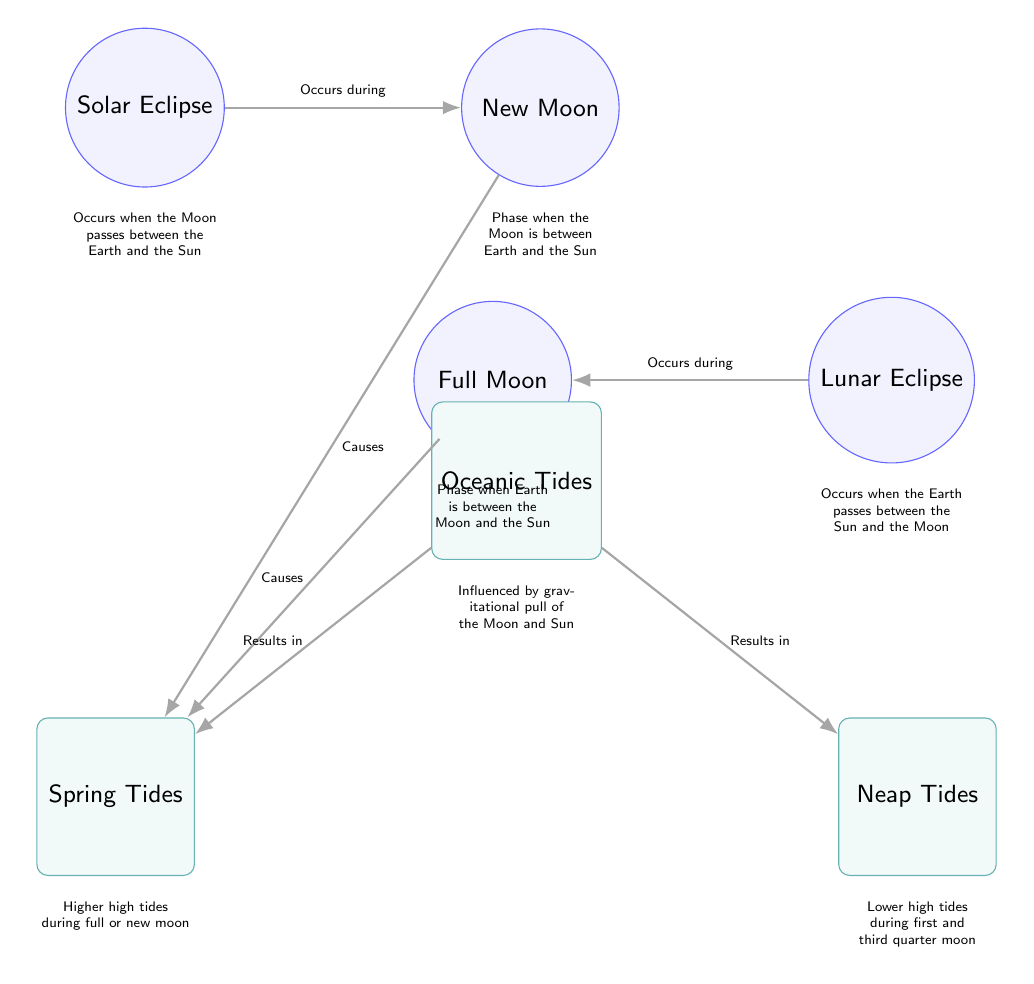What two celestial events are connected to spring tides? The diagram shows that both the new moon and full moon are linked to spring tides, indicating that these lunar phases cause higher tides.
Answer: new moon, full moon How many types of tides are represented in the diagram? There are two types of tides shown: spring tides and neap tides. The diagram clearly illustrates both types beneath the oceanic tides node.
Answer: 2 What phase does a solar eclipse occur during? The diagram states that a solar eclipse occurs during the new moon, as depicted by the arrow connecting these two nodes.
Answer: New Moon Which type of tide results from a full moon? According to the diagram, a full moon is associated with spring tides, indicated by the connection of the full moon node to the spring tides node.
Answer: Spring Tides What do oceanic tides result from? The diagram specifies that oceanic tides are influenced by the gravitational pull of both the Moon and the Sun, as indicated in the node description beneath the ocean node.
Answer: Gravitational pull of the Moon and Sun Which event occurs when the Earth is between the Sun and the Moon? The diagram indicates that a lunar eclipse occurs under this scenario, as it connects the Earth, Moon, and Sun in the given context.
Answer: Lunar Eclipse What are the characteristics of neap tides? The diagram describes neap tides as having lower high tides during the first and third quarter moon, as stated in the node description associated with neap tides.
Answer: Lower high tides during first and third quarter moon During which lunar phase do solar eclipses occur? The diagram specifically states that solar eclipses occur during the new moon phase, as visually indicated by the connecting arrow to the new moon node.
Answer: New Moon What is the relationship between spring tides and oceanic tides? The diagram shows that spring tides are a result of oceanic tides, as indicated by the direct connection leading from the ocean node to the spring tides node.
Answer: Results in Spring Tides 